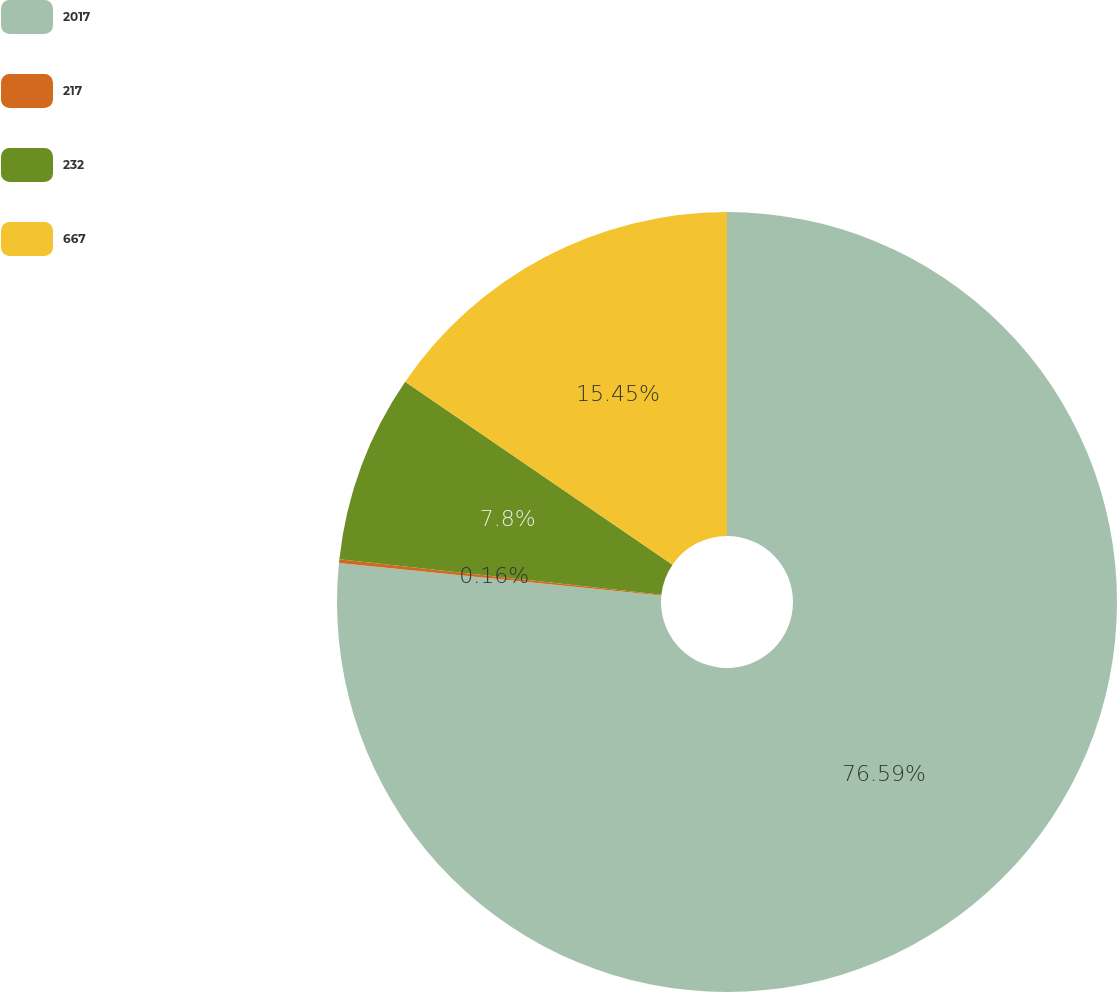Convert chart to OTSL. <chart><loc_0><loc_0><loc_500><loc_500><pie_chart><fcel>2017<fcel>217<fcel>232<fcel>667<nl><fcel>76.6%<fcel>0.16%<fcel>7.8%<fcel>15.45%<nl></chart> 